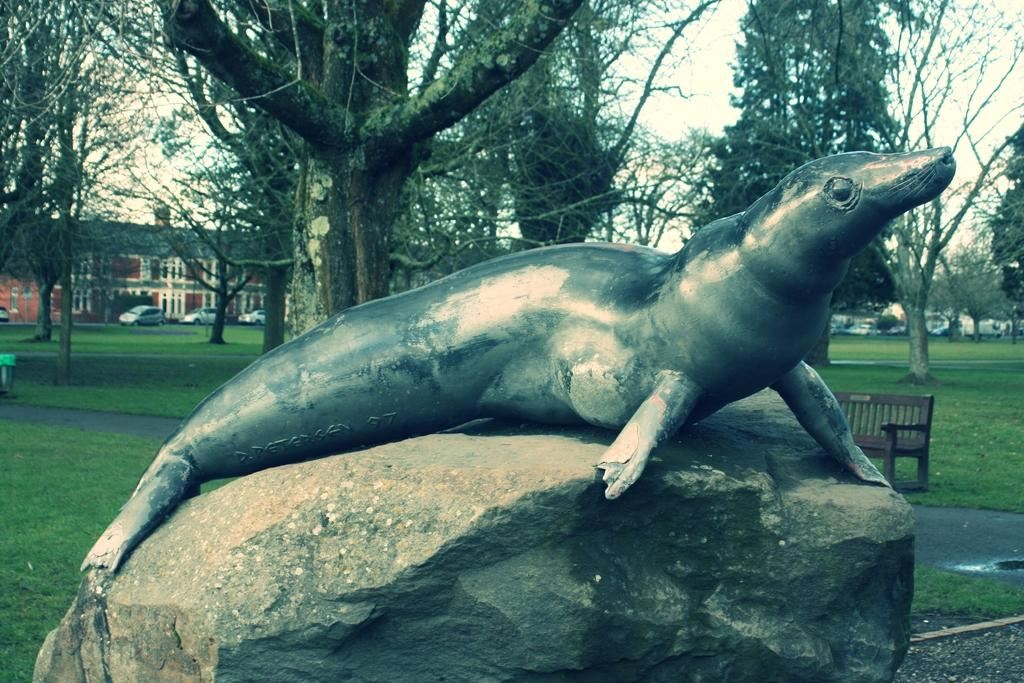What is located on a rock in the image? There is a statue on a rock in the image. What type of seating is visible in the background of the image? There is a bench on the ground in the background of the image. What type of vegetation can be seen in the background of the image? There are trees in the background of the image. What type of structure is visible in the background of the image? There is a building in the background of the image. What type of vehicles are in front of the building in the background of the image? There are cars in front of the building in the background of the image. What part of the natural environment is visible in the background of the image? The sky is visible in the background of the image. How many dimes are scattered around the statue in the image? There are no dimes present in the image; it features a statue on a rock, a bench, trees, a building, cars, and the sky. 